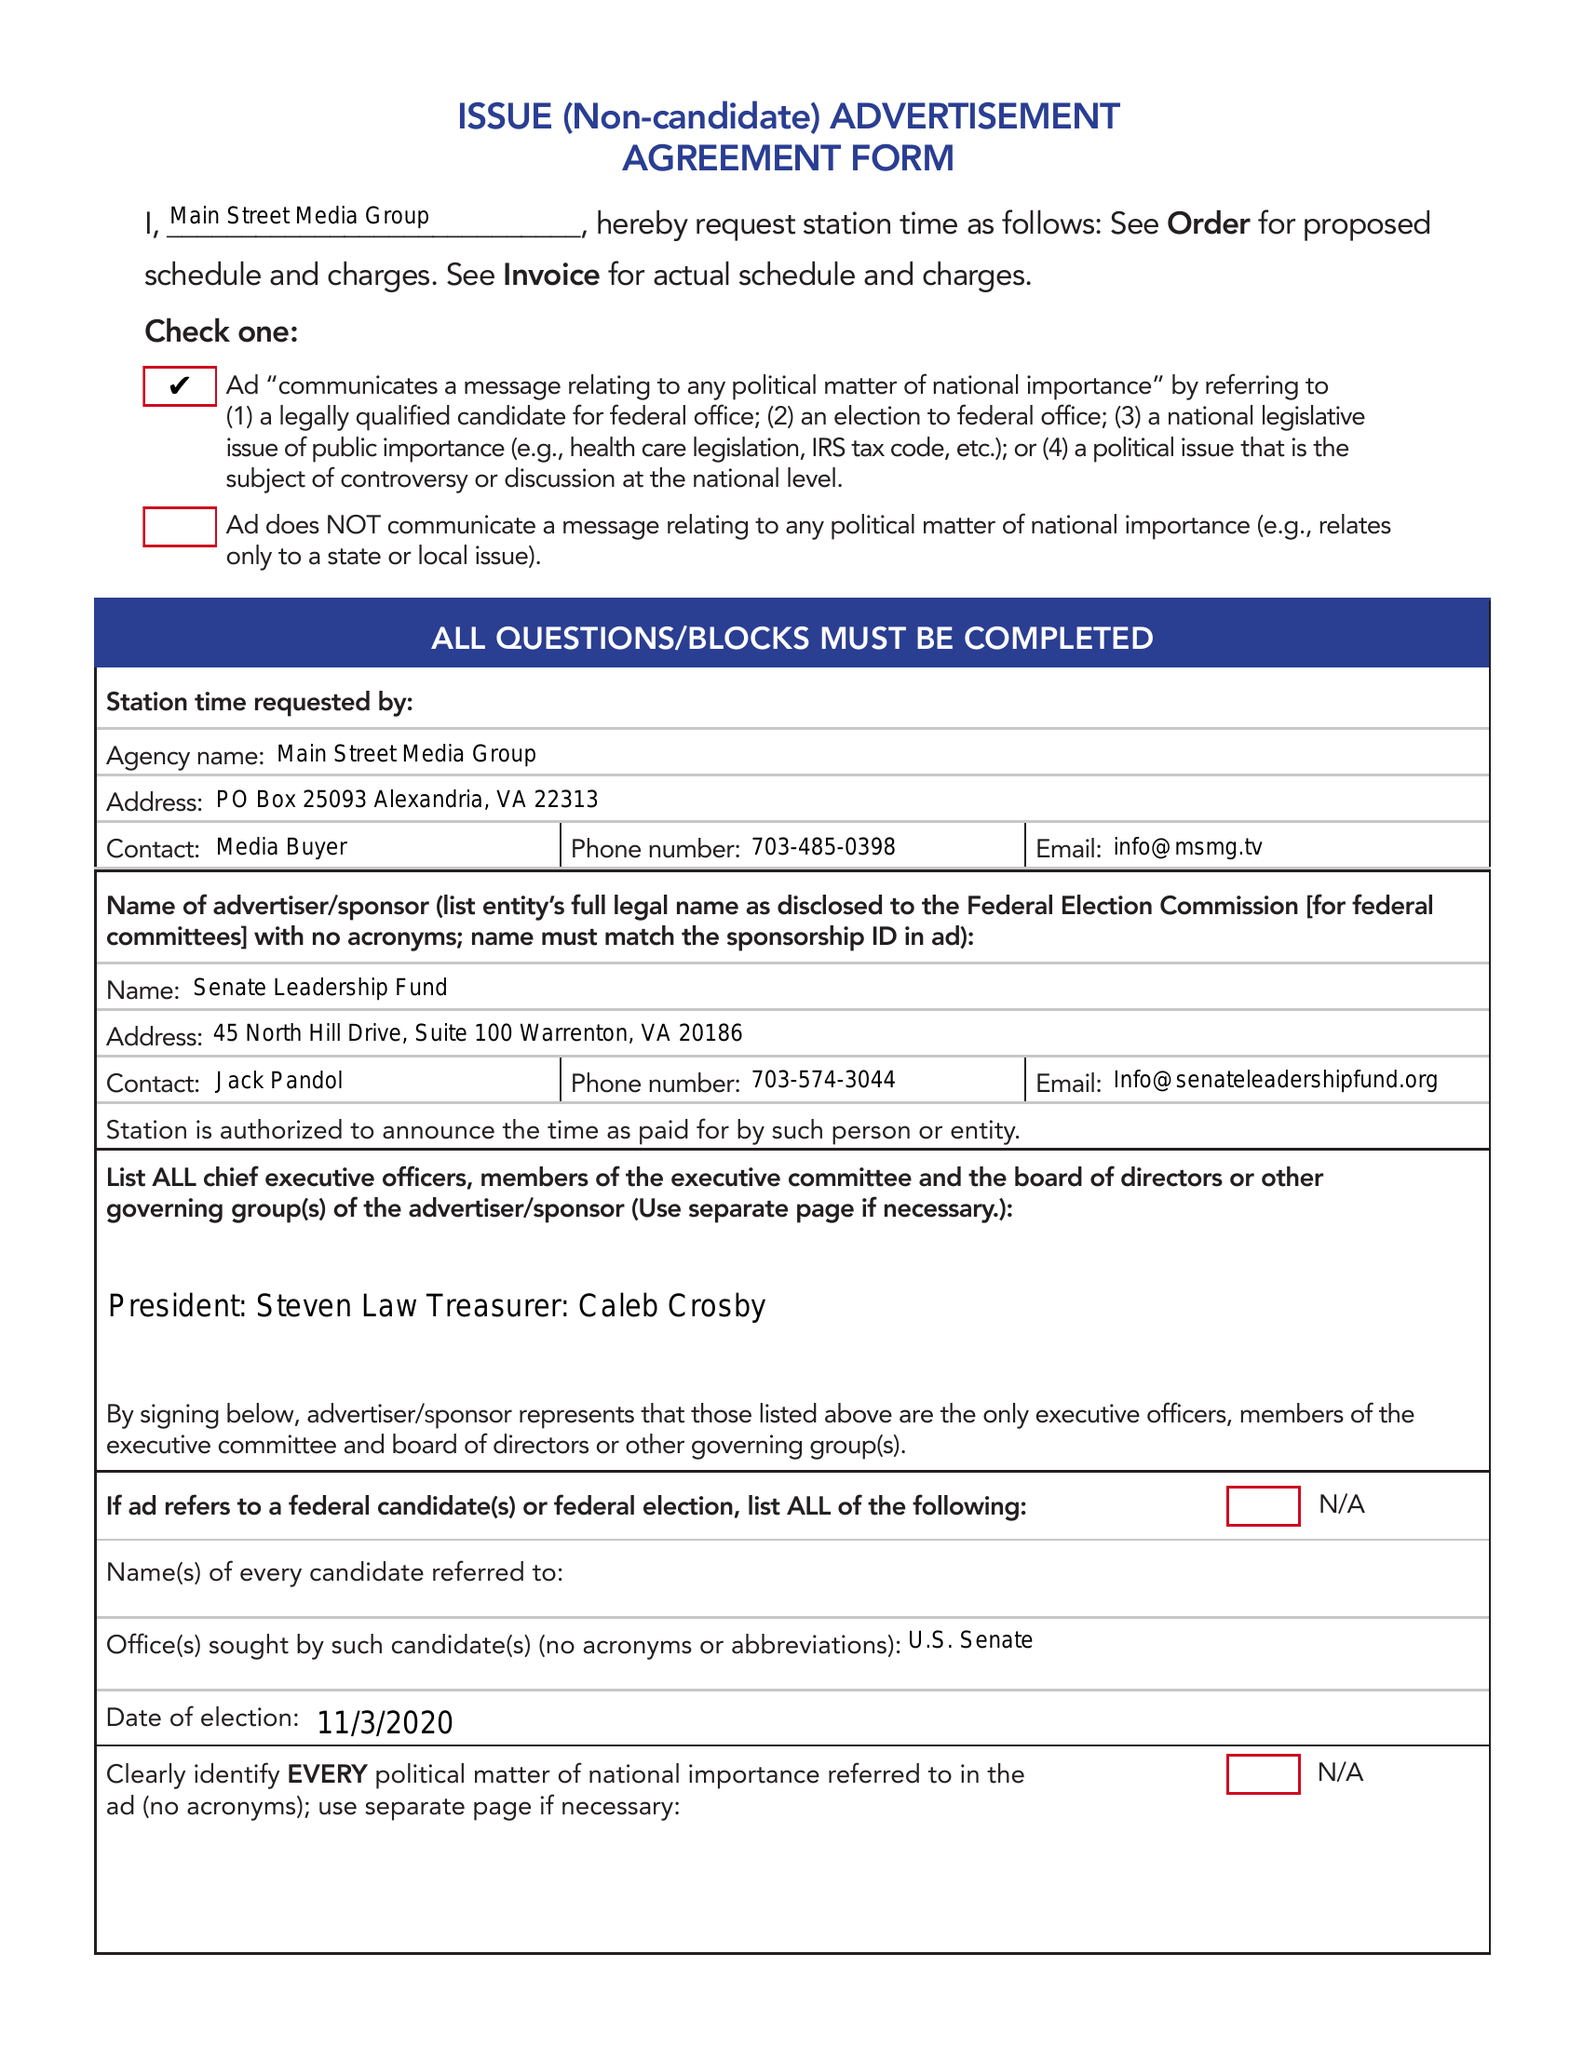What is the value for the flight_from?
Answer the question using a single word or phrase. 10/20/20 